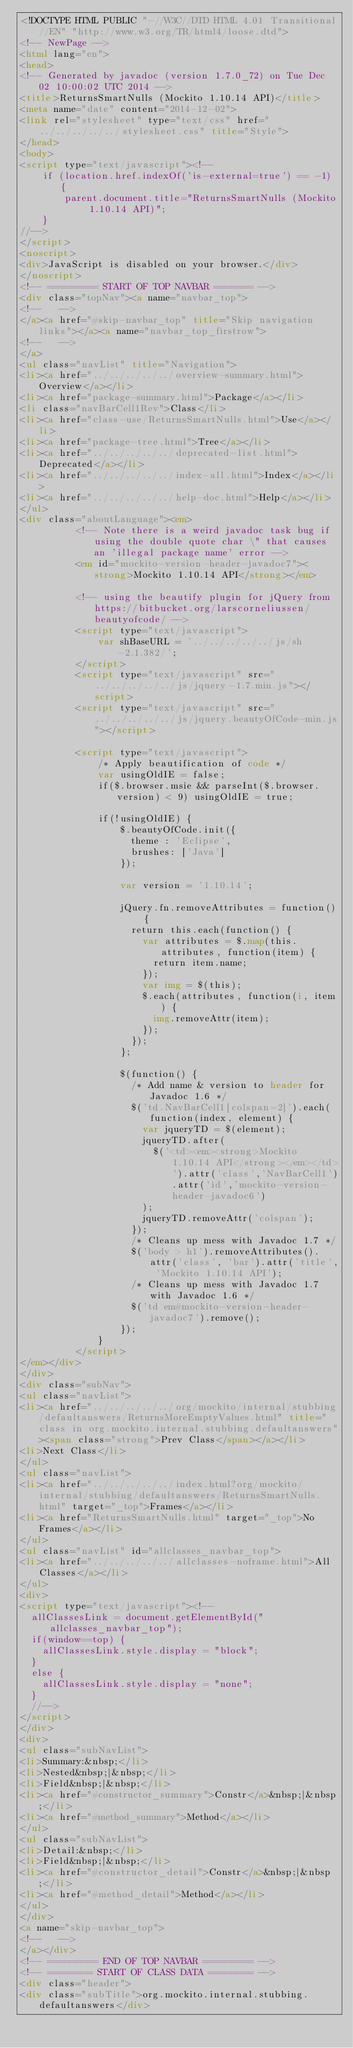Convert code to text. <code><loc_0><loc_0><loc_500><loc_500><_HTML_><!DOCTYPE HTML PUBLIC "-//W3C//DTD HTML 4.01 Transitional//EN" "http://www.w3.org/TR/html4/loose.dtd">
<!-- NewPage -->
<html lang="en">
<head>
<!-- Generated by javadoc (version 1.7.0_72) on Tue Dec 02 10:00:02 UTC 2014 -->
<title>ReturnsSmartNulls (Mockito 1.10.14 API)</title>
<meta name="date" content="2014-12-02">
<link rel="stylesheet" type="text/css" href="../../../../../stylesheet.css" title="Style">
</head>
<body>
<script type="text/javascript"><!--
    if (location.href.indexOf('is-external=true') == -1) {
        parent.document.title="ReturnsSmartNulls (Mockito 1.10.14 API)";
    }
//-->
</script>
<noscript>
<div>JavaScript is disabled on your browser.</div>
</noscript>
<!-- ========= START OF TOP NAVBAR ======= -->
<div class="topNav"><a name="navbar_top">
<!--   -->
</a><a href="#skip-navbar_top" title="Skip navigation links"></a><a name="navbar_top_firstrow">
<!--   -->
</a>
<ul class="navList" title="Navigation">
<li><a href="../../../../../overview-summary.html">Overview</a></li>
<li><a href="package-summary.html">Package</a></li>
<li class="navBarCell1Rev">Class</li>
<li><a href="class-use/ReturnsSmartNulls.html">Use</a></li>
<li><a href="package-tree.html">Tree</a></li>
<li><a href="../../../../../deprecated-list.html">Deprecated</a></li>
<li><a href="../../../../../index-all.html">Index</a></li>
<li><a href="../../../../../help-doc.html">Help</a></li>
</ul>
<div class="aboutLanguage"><em>
          <!-- Note there is a weird javadoc task bug if using the double quote char \" that causes an 'illegal package name' error -->
          <em id="mockito-version-header-javadoc7"><strong>Mockito 1.10.14 API</strong></em>

          <!-- using the beautify plugin for jQuery from https://bitbucket.org/larscorneliussen/beautyofcode/ -->
          <script type="text/javascript">
              var shBaseURL = '../../../../../js/sh-2.1.382/';
          </script>
          <script type="text/javascript" src="../../../../../js/jquery-1.7.min.js"></script>
          <script type="text/javascript" src="../../../../../js/jquery.beautyOfCode-min.js"></script>

          <script type="text/javascript">
              /* Apply beautification of code */
              var usingOldIE = false;
              if($.browser.msie && parseInt($.browser.version) < 9) usingOldIE = true;

              if(!usingOldIE) {
                  $.beautyOfCode.init({
                    theme : 'Eclipse',
                    brushes: ['Java']
                  });

                  var version = '1.10.14';

                  jQuery.fn.removeAttributes = function() {
                    return this.each(function() {
                      var attributes = $.map(this.attributes, function(item) {
                        return item.name;
                      });
                      var img = $(this);
                      $.each(attributes, function(i, item) {
                        img.removeAttr(item);
                      });
                    });
                  };

                  $(function() {
                    /* Add name & version to header for Javadoc 1.6 */
                    $('td.NavBarCell1[colspan=2]').each(function(index, element) {
                      var jqueryTD = $(element);
                      jqueryTD.after(
                        $('<td><em><strong>Mockito 1.10.14 API</strong></em></td>').attr('class','NavBarCell1').attr('id','mockito-version-header-javadoc6')
                      );
                      jqueryTD.removeAttr('colspan');
                    });
                    /* Cleans up mess with Javadoc 1.7 */
                    $('body > h1').removeAttributes().attr('class', 'bar').attr('title', 'Mockito 1.10.14 API');
                    /* Cleans up mess with Javadoc 1.7 with Javadoc 1.6 */
                    $('td em#mockito-version-header-javadoc7').remove();
                  });
              }
          </script>
</em></div>
</div>
<div class="subNav">
<ul class="navList">
<li><a href="../../../../../org/mockito/internal/stubbing/defaultanswers/ReturnsMoreEmptyValues.html" title="class in org.mockito.internal.stubbing.defaultanswers"><span class="strong">Prev Class</span></a></li>
<li>Next Class</li>
</ul>
<ul class="navList">
<li><a href="../../../../../index.html?org/mockito/internal/stubbing/defaultanswers/ReturnsSmartNulls.html" target="_top">Frames</a></li>
<li><a href="ReturnsSmartNulls.html" target="_top">No Frames</a></li>
</ul>
<ul class="navList" id="allclasses_navbar_top">
<li><a href="../../../../../allclasses-noframe.html">All Classes</a></li>
</ul>
<div>
<script type="text/javascript"><!--
  allClassesLink = document.getElementById("allclasses_navbar_top");
  if(window==top) {
    allClassesLink.style.display = "block";
  }
  else {
    allClassesLink.style.display = "none";
  }
  //-->
</script>
</div>
<div>
<ul class="subNavList">
<li>Summary:&nbsp;</li>
<li>Nested&nbsp;|&nbsp;</li>
<li>Field&nbsp;|&nbsp;</li>
<li><a href="#constructor_summary">Constr</a>&nbsp;|&nbsp;</li>
<li><a href="#method_summary">Method</a></li>
</ul>
<ul class="subNavList">
<li>Detail:&nbsp;</li>
<li>Field&nbsp;|&nbsp;</li>
<li><a href="#constructor_detail">Constr</a>&nbsp;|&nbsp;</li>
<li><a href="#method_detail">Method</a></li>
</ul>
</div>
<a name="skip-navbar_top">
<!--   -->
</a></div>
<!-- ========= END OF TOP NAVBAR ========= -->
<!-- ======== START OF CLASS DATA ======== -->
<div class="header">
<div class="subTitle">org.mockito.internal.stubbing.defaultanswers</div></code> 